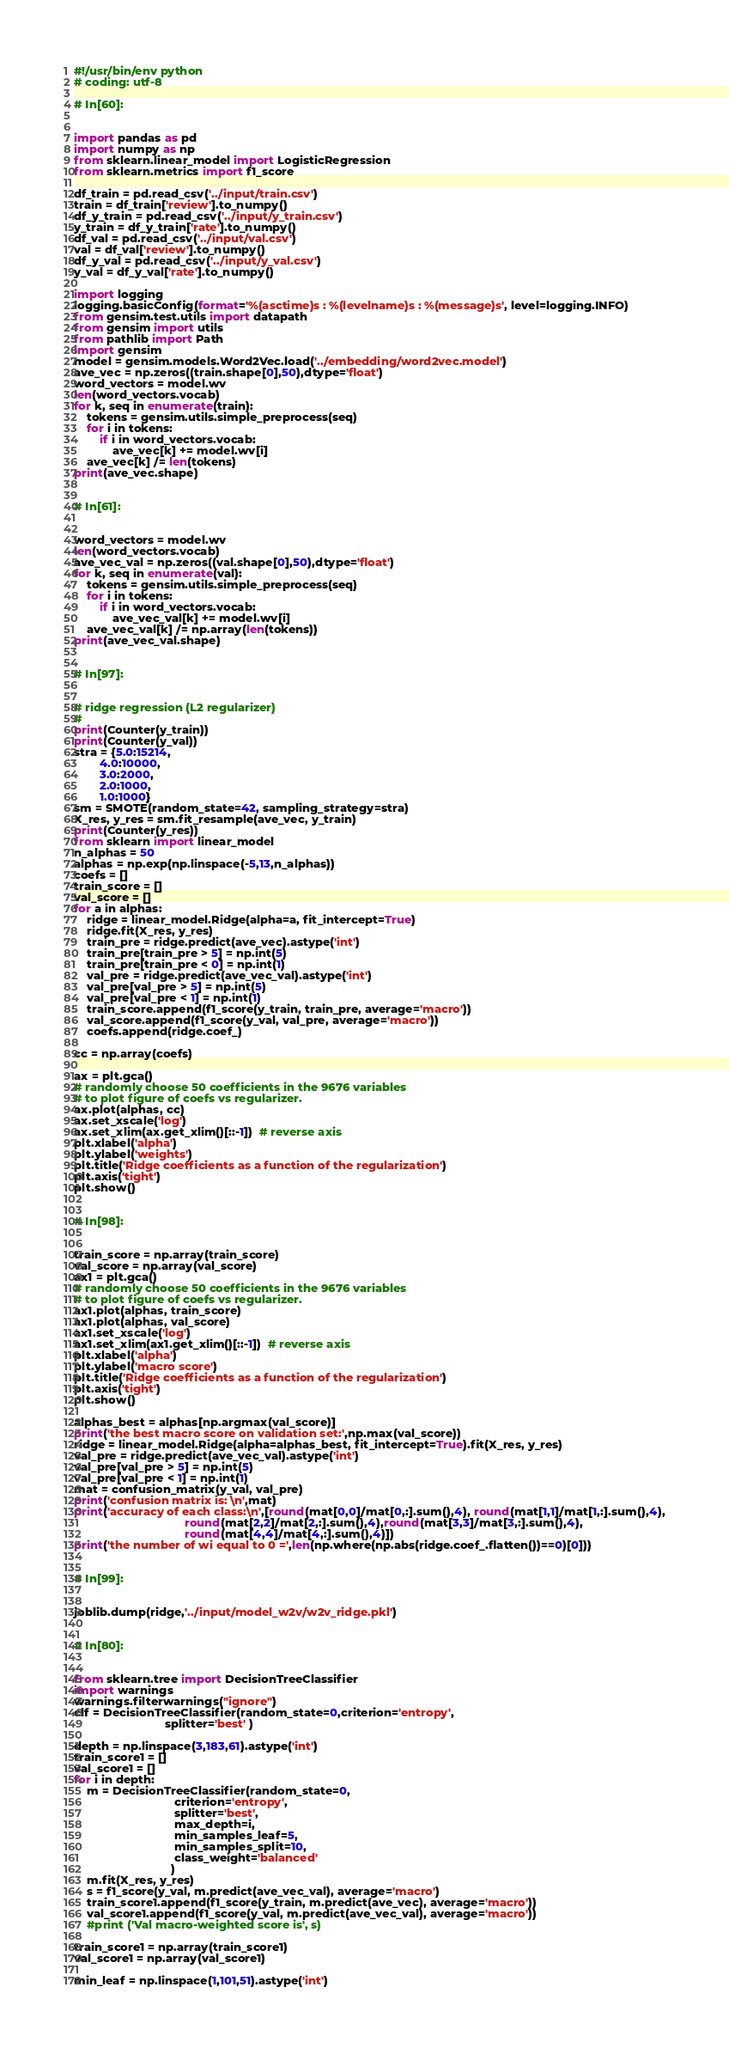Convert code to text. <code><loc_0><loc_0><loc_500><loc_500><_Python_>#!/usr/bin/env python
# coding: utf-8

# In[60]:


import pandas as pd 
import numpy as np
from sklearn.linear_model import LogisticRegression
from sklearn.metrics import f1_score

df_train = pd.read_csv('../input/train.csv')
train = df_train['review'].to_numpy()
df_y_train = pd.read_csv('../input/y_train.csv')
y_train = df_y_train['rate'].to_numpy()
df_val = pd.read_csv('../input/val.csv')
val = df_val['review'].to_numpy()
df_y_val = pd.read_csv('../input/y_val.csv')
y_val = df_y_val['rate'].to_numpy()

import logging
logging.basicConfig(format='%(asctime)s : %(levelname)s : %(message)s', level=logging.INFO)
from gensim.test.utils import datapath
from gensim import utils
from pathlib import Path
import gensim
model = gensim.models.Word2Vec.load('../embedding/word2vec.model')
ave_vec = np.zeros((train.shape[0],50),dtype='float')
word_vectors = model.wv
len(word_vectors.vocab)
for k, seq in enumerate(train):
    tokens = gensim.utils.simple_preprocess(seq)
    for i in tokens:
        if i in word_vectors.vocab: 
            ave_vec[k] += model.wv[i]
    ave_vec[k] /= len(tokens)
print(ave_vec.shape)


# In[61]:


word_vectors = model.wv
len(word_vectors.vocab)
ave_vec_val = np.zeros((val.shape[0],50),dtype='float')
for k, seq in enumerate(val):
    tokens = gensim.utils.simple_preprocess(seq)
    for i in tokens:
        if i in word_vectors.vocab: 
            ave_vec_val[k] += model.wv[i]
    ave_vec_val[k] /= np.array(len(tokens))
print(ave_vec_val.shape)


# In[97]:


# ridge regression (L2 regularizer)
# 
print(Counter(y_train))
print(Counter(y_val))
stra = {5.0:15214,
        4.0:10000, 
        3.0:2000,
        2.0:1000,
        1.0:1000}
sm = SMOTE(random_state=42, sampling_strategy=stra)
X_res, y_res = sm.fit_resample(ave_vec, y_train)
print(Counter(y_res))
from sklearn import linear_model
n_alphas = 50
alphas = np.exp(np.linspace(-5,13,n_alphas))
coefs = []
train_score = []
val_score = []
for a in alphas:
    ridge = linear_model.Ridge(alpha=a, fit_intercept=True)
    ridge.fit(X_res, y_res)
    train_pre = ridge.predict(ave_vec).astype('int')
    train_pre[train_pre > 5] = np.int(5)
    train_pre[train_pre < 0] = np.int(1)
    val_pre = ridge.predict(ave_vec_val).astype('int')
    val_pre[val_pre > 5] = np.int(5)
    val_pre[val_pre < 1] = np.int(1)
    train_score.append(f1_score(y_train, train_pre, average='macro'))
    val_score.append(f1_score(y_val, val_pre, average='macro'))
    coefs.append(ridge.coef_)
    
cc = np.array(coefs)

ax = plt.gca()
# randomly choose 50 coefficients in the 9676 variables 
# to plot figure of coefs vs regularizer. 
ax.plot(alphas, cc)
ax.set_xscale('log')
ax.set_xlim(ax.get_xlim()[::-1])  # reverse axis
plt.xlabel('alpha')
plt.ylabel('weights')
plt.title('Ridge coefficients as a function of the regularization')
plt.axis('tight')
plt.show()


# In[98]:


train_score = np.array(train_score)
val_score = np.array(val_score)
ax1 = plt.gca()
# randomly choose 50 coefficients in the 9676 variables 
# to plot figure of coefs vs regularizer. 
ax1.plot(alphas, train_score)
ax1.plot(alphas, val_score)
ax1.set_xscale('log')
ax1.set_xlim(ax1.get_xlim()[::-1])  # reverse axis
plt.xlabel('alpha')
plt.ylabel('macro score')
plt.title('Ridge coefficients as a function of the regularization')
plt.axis('tight')
plt.show()

alphas_best = alphas[np.argmax(val_score)]
print('the best macro score on validation set:',np.max(val_score))
ridge = linear_model.Ridge(alpha=alphas_best, fit_intercept=True).fit(X_res, y_res)
val_pre = ridge.predict(ave_vec_val).astype('int')
val_pre[val_pre > 5] = np.int(5)
val_pre[val_pre < 1] = np.int(1)
mat = confusion_matrix(y_val, val_pre)
print('confusion matrix is: \n',mat)
print('accuracy of each class:\n',[round(mat[0,0]/mat[0,:].sum(),4), round(mat[1,1]/mat[1,:].sum(),4),
                                  round(mat[2,2]/mat[2,:].sum(),4),round(mat[3,3]/mat[3,:].sum(),4),
                                  round(mat[4,4]/mat[4,:].sum(),4)])
print('the number of wi equal to 0 =',len(np.where(np.abs(ridge.coef_.flatten())==0)[0]))


# In[99]:


joblib.dump(ridge,'../input/model_w2v/w2v_ridge.pkl')


# In[80]:


from sklearn.tree import DecisionTreeClassifier
import warnings
warnings.filterwarnings("ignore")
clf = DecisionTreeClassifier(random_state=0,criterion='entropy',
                            splitter='best' )

depth = np.linspace(3,183,61).astype('int')
train_score1 = []
val_score1 = []
for i in depth:
    m = DecisionTreeClassifier(random_state=0,
                               criterion='entropy',
                               splitter='best',
                               max_depth=i,
                               min_samples_leaf=5,
                               min_samples_split=10, 
                               class_weight='balanced'
                              )
    m.fit(X_res, y_res)
    s = f1_score(y_val, m.predict(ave_vec_val), average='macro')
    train_score1.append(f1_score(y_train, m.predict(ave_vec), average='macro'))
    val_score1.append(f1_score(y_val, m.predict(ave_vec_val), average='macro'))
    #print ('Val macro-weighted score is', s)

train_score1 = np.array(train_score1)
val_score1 = np.array(val_score1)

min_leaf = np.linspace(1,101,51).astype('int')</code> 